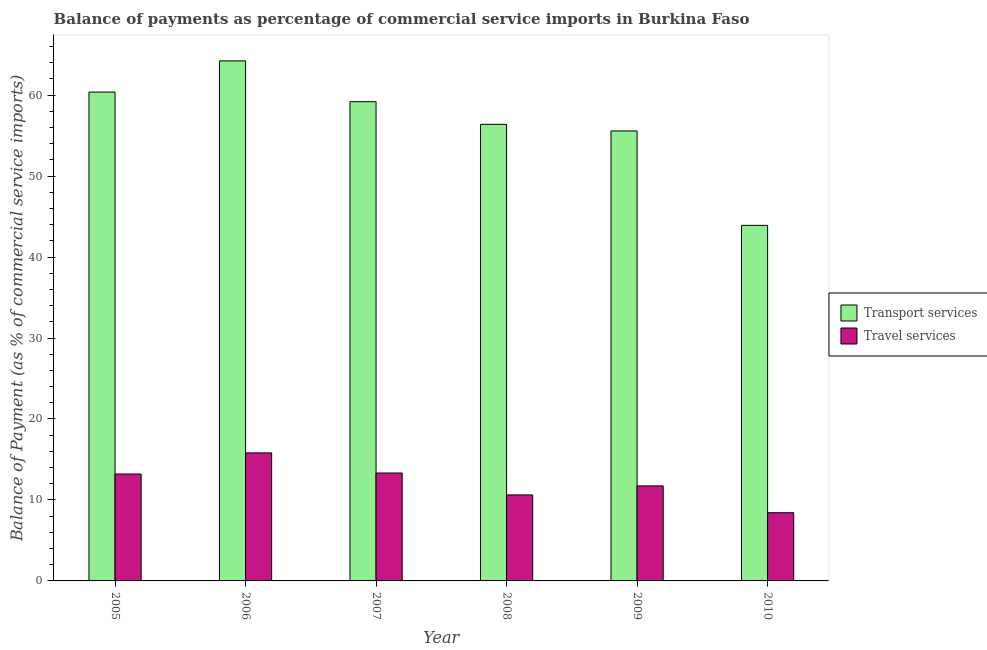How many groups of bars are there?
Provide a short and direct response. 6. How many bars are there on the 3rd tick from the left?
Give a very brief answer. 2. In how many cases, is the number of bars for a given year not equal to the number of legend labels?
Offer a terse response. 0. What is the balance of payments of transport services in 2006?
Ensure brevity in your answer.  64.23. Across all years, what is the maximum balance of payments of travel services?
Provide a succinct answer. 15.81. Across all years, what is the minimum balance of payments of travel services?
Keep it short and to the point. 8.42. What is the total balance of payments of transport services in the graph?
Your answer should be very brief. 339.65. What is the difference between the balance of payments of travel services in 2009 and that in 2010?
Your answer should be compact. 3.31. What is the difference between the balance of payments of transport services in 2006 and the balance of payments of travel services in 2008?
Keep it short and to the point. 7.84. What is the average balance of payments of travel services per year?
Provide a succinct answer. 12.19. In the year 2010, what is the difference between the balance of payments of travel services and balance of payments of transport services?
Ensure brevity in your answer.  0. In how many years, is the balance of payments of transport services greater than 58 %?
Make the answer very short. 3. What is the ratio of the balance of payments of travel services in 2005 to that in 2009?
Give a very brief answer. 1.13. Is the difference between the balance of payments of travel services in 2007 and 2010 greater than the difference between the balance of payments of transport services in 2007 and 2010?
Ensure brevity in your answer.  No. What is the difference between the highest and the second highest balance of payments of transport services?
Provide a short and direct response. 3.85. What is the difference between the highest and the lowest balance of payments of travel services?
Give a very brief answer. 7.39. Is the sum of the balance of payments of travel services in 2007 and 2008 greater than the maximum balance of payments of transport services across all years?
Offer a terse response. Yes. What does the 1st bar from the left in 2010 represents?
Give a very brief answer. Transport services. What does the 2nd bar from the right in 2010 represents?
Offer a terse response. Transport services. Are all the bars in the graph horizontal?
Keep it short and to the point. No. Are the values on the major ticks of Y-axis written in scientific E-notation?
Offer a very short reply. No. Does the graph contain grids?
Your answer should be very brief. No. Where does the legend appear in the graph?
Make the answer very short. Center right. What is the title of the graph?
Make the answer very short. Balance of payments as percentage of commercial service imports in Burkina Faso. Does "Boys" appear as one of the legend labels in the graph?
Provide a short and direct response. No. What is the label or title of the Y-axis?
Your answer should be compact. Balance of Payment (as % of commercial service imports). What is the Balance of Payment (as % of commercial service imports) in Transport services in 2005?
Ensure brevity in your answer.  60.37. What is the Balance of Payment (as % of commercial service imports) in Travel services in 2005?
Your answer should be very brief. 13.2. What is the Balance of Payment (as % of commercial service imports) in Transport services in 2006?
Offer a very short reply. 64.23. What is the Balance of Payment (as % of commercial service imports) of Travel services in 2006?
Ensure brevity in your answer.  15.81. What is the Balance of Payment (as % of commercial service imports) of Transport services in 2007?
Your response must be concise. 59.19. What is the Balance of Payment (as % of commercial service imports) of Travel services in 2007?
Keep it short and to the point. 13.33. What is the Balance of Payment (as % of commercial service imports) of Transport services in 2008?
Offer a terse response. 56.39. What is the Balance of Payment (as % of commercial service imports) in Travel services in 2008?
Give a very brief answer. 10.62. What is the Balance of Payment (as % of commercial service imports) of Transport services in 2009?
Your response must be concise. 55.57. What is the Balance of Payment (as % of commercial service imports) in Travel services in 2009?
Offer a very short reply. 11.73. What is the Balance of Payment (as % of commercial service imports) in Transport services in 2010?
Your answer should be very brief. 43.91. What is the Balance of Payment (as % of commercial service imports) of Travel services in 2010?
Provide a short and direct response. 8.42. Across all years, what is the maximum Balance of Payment (as % of commercial service imports) in Transport services?
Keep it short and to the point. 64.23. Across all years, what is the maximum Balance of Payment (as % of commercial service imports) of Travel services?
Provide a short and direct response. 15.81. Across all years, what is the minimum Balance of Payment (as % of commercial service imports) in Transport services?
Keep it short and to the point. 43.91. Across all years, what is the minimum Balance of Payment (as % of commercial service imports) of Travel services?
Provide a succinct answer. 8.42. What is the total Balance of Payment (as % of commercial service imports) of Transport services in the graph?
Keep it short and to the point. 339.65. What is the total Balance of Payment (as % of commercial service imports) of Travel services in the graph?
Your answer should be compact. 73.12. What is the difference between the Balance of Payment (as % of commercial service imports) in Transport services in 2005 and that in 2006?
Offer a terse response. -3.85. What is the difference between the Balance of Payment (as % of commercial service imports) in Travel services in 2005 and that in 2006?
Provide a succinct answer. -2.61. What is the difference between the Balance of Payment (as % of commercial service imports) of Transport services in 2005 and that in 2007?
Offer a very short reply. 1.19. What is the difference between the Balance of Payment (as % of commercial service imports) in Travel services in 2005 and that in 2007?
Your answer should be very brief. -0.12. What is the difference between the Balance of Payment (as % of commercial service imports) of Transport services in 2005 and that in 2008?
Ensure brevity in your answer.  3.98. What is the difference between the Balance of Payment (as % of commercial service imports) of Travel services in 2005 and that in 2008?
Offer a terse response. 2.58. What is the difference between the Balance of Payment (as % of commercial service imports) in Transport services in 2005 and that in 2009?
Provide a succinct answer. 4.8. What is the difference between the Balance of Payment (as % of commercial service imports) in Travel services in 2005 and that in 2009?
Your answer should be very brief. 1.47. What is the difference between the Balance of Payment (as % of commercial service imports) of Transport services in 2005 and that in 2010?
Offer a terse response. 16.46. What is the difference between the Balance of Payment (as % of commercial service imports) in Travel services in 2005 and that in 2010?
Provide a succinct answer. 4.78. What is the difference between the Balance of Payment (as % of commercial service imports) of Transport services in 2006 and that in 2007?
Make the answer very short. 5.04. What is the difference between the Balance of Payment (as % of commercial service imports) of Travel services in 2006 and that in 2007?
Give a very brief answer. 2.48. What is the difference between the Balance of Payment (as % of commercial service imports) in Transport services in 2006 and that in 2008?
Offer a terse response. 7.84. What is the difference between the Balance of Payment (as % of commercial service imports) of Travel services in 2006 and that in 2008?
Offer a terse response. 5.19. What is the difference between the Balance of Payment (as % of commercial service imports) in Transport services in 2006 and that in 2009?
Your answer should be compact. 8.66. What is the difference between the Balance of Payment (as % of commercial service imports) in Travel services in 2006 and that in 2009?
Provide a short and direct response. 4.08. What is the difference between the Balance of Payment (as % of commercial service imports) of Transport services in 2006 and that in 2010?
Keep it short and to the point. 20.31. What is the difference between the Balance of Payment (as % of commercial service imports) in Travel services in 2006 and that in 2010?
Offer a very short reply. 7.39. What is the difference between the Balance of Payment (as % of commercial service imports) in Transport services in 2007 and that in 2008?
Make the answer very short. 2.8. What is the difference between the Balance of Payment (as % of commercial service imports) of Travel services in 2007 and that in 2008?
Give a very brief answer. 2.71. What is the difference between the Balance of Payment (as % of commercial service imports) in Transport services in 2007 and that in 2009?
Your answer should be very brief. 3.61. What is the difference between the Balance of Payment (as % of commercial service imports) of Travel services in 2007 and that in 2009?
Provide a succinct answer. 1.59. What is the difference between the Balance of Payment (as % of commercial service imports) in Transport services in 2007 and that in 2010?
Provide a short and direct response. 15.27. What is the difference between the Balance of Payment (as % of commercial service imports) in Travel services in 2007 and that in 2010?
Provide a short and direct response. 4.9. What is the difference between the Balance of Payment (as % of commercial service imports) of Transport services in 2008 and that in 2009?
Your answer should be compact. 0.82. What is the difference between the Balance of Payment (as % of commercial service imports) in Travel services in 2008 and that in 2009?
Your answer should be very brief. -1.11. What is the difference between the Balance of Payment (as % of commercial service imports) of Transport services in 2008 and that in 2010?
Offer a very short reply. 12.48. What is the difference between the Balance of Payment (as % of commercial service imports) of Travel services in 2008 and that in 2010?
Offer a very short reply. 2.2. What is the difference between the Balance of Payment (as % of commercial service imports) of Transport services in 2009 and that in 2010?
Offer a very short reply. 11.66. What is the difference between the Balance of Payment (as % of commercial service imports) of Travel services in 2009 and that in 2010?
Your answer should be very brief. 3.31. What is the difference between the Balance of Payment (as % of commercial service imports) of Transport services in 2005 and the Balance of Payment (as % of commercial service imports) of Travel services in 2006?
Offer a terse response. 44.56. What is the difference between the Balance of Payment (as % of commercial service imports) in Transport services in 2005 and the Balance of Payment (as % of commercial service imports) in Travel services in 2007?
Ensure brevity in your answer.  47.05. What is the difference between the Balance of Payment (as % of commercial service imports) in Transport services in 2005 and the Balance of Payment (as % of commercial service imports) in Travel services in 2008?
Ensure brevity in your answer.  49.75. What is the difference between the Balance of Payment (as % of commercial service imports) of Transport services in 2005 and the Balance of Payment (as % of commercial service imports) of Travel services in 2009?
Your answer should be compact. 48.64. What is the difference between the Balance of Payment (as % of commercial service imports) in Transport services in 2005 and the Balance of Payment (as % of commercial service imports) in Travel services in 2010?
Your answer should be very brief. 51.95. What is the difference between the Balance of Payment (as % of commercial service imports) of Transport services in 2006 and the Balance of Payment (as % of commercial service imports) of Travel services in 2007?
Give a very brief answer. 50.9. What is the difference between the Balance of Payment (as % of commercial service imports) of Transport services in 2006 and the Balance of Payment (as % of commercial service imports) of Travel services in 2008?
Provide a succinct answer. 53.61. What is the difference between the Balance of Payment (as % of commercial service imports) in Transport services in 2006 and the Balance of Payment (as % of commercial service imports) in Travel services in 2009?
Make the answer very short. 52.49. What is the difference between the Balance of Payment (as % of commercial service imports) in Transport services in 2006 and the Balance of Payment (as % of commercial service imports) in Travel services in 2010?
Offer a terse response. 55.8. What is the difference between the Balance of Payment (as % of commercial service imports) in Transport services in 2007 and the Balance of Payment (as % of commercial service imports) in Travel services in 2008?
Give a very brief answer. 48.56. What is the difference between the Balance of Payment (as % of commercial service imports) of Transport services in 2007 and the Balance of Payment (as % of commercial service imports) of Travel services in 2009?
Keep it short and to the point. 47.45. What is the difference between the Balance of Payment (as % of commercial service imports) of Transport services in 2007 and the Balance of Payment (as % of commercial service imports) of Travel services in 2010?
Provide a succinct answer. 50.76. What is the difference between the Balance of Payment (as % of commercial service imports) in Transport services in 2008 and the Balance of Payment (as % of commercial service imports) in Travel services in 2009?
Give a very brief answer. 44.65. What is the difference between the Balance of Payment (as % of commercial service imports) of Transport services in 2008 and the Balance of Payment (as % of commercial service imports) of Travel services in 2010?
Provide a short and direct response. 47.97. What is the difference between the Balance of Payment (as % of commercial service imports) of Transport services in 2009 and the Balance of Payment (as % of commercial service imports) of Travel services in 2010?
Your answer should be very brief. 47.15. What is the average Balance of Payment (as % of commercial service imports) of Transport services per year?
Ensure brevity in your answer.  56.61. What is the average Balance of Payment (as % of commercial service imports) in Travel services per year?
Ensure brevity in your answer.  12.19. In the year 2005, what is the difference between the Balance of Payment (as % of commercial service imports) in Transport services and Balance of Payment (as % of commercial service imports) in Travel services?
Your answer should be compact. 47.17. In the year 2006, what is the difference between the Balance of Payment (as % of commercial service imports) in Transport services and Balance of Payment (as % of commercial service imports) in Travel services?
Your answer should be compact. 48.42. In the year 2007, what is the difference between the Balance of Payment (as % of commercial service imports) of Transport services and Balance of Payment (as % of commercial service imports) of Travel services?
Make the answer very short. 45.86. In the year 2008, what is the difference between the Balance of Payment (as % of commercial service imports) of Transport services and Balance of Payment (as % of commercial service imports) of Travel services?
Give a very brief answer. 45.77. In the year 2009, what is the difference between the Balance of Payment (as % of commercial service imports) of Transport services and Balance of Payment (as % of commercial service imports) of Travel services?
Provide a short and direct response. 43.84. In the year 2010, what is the difference between the Balance of Payment (as % of commercial service imports) of Transport services and Balance of Payment (as % of commercial service imports) of Travel services?
Provide a short and direct response. 35.49. What is the ratio of the Balance of Payment (as % of commercial service imports) of Travel services in 2005 to that in 2006?
Your answer should be very brief. 0.83. What is the ratio of the Balance of Payment (as % of commercial service imports) in Transport services in 2005 to that in 2007?
Your answer should be compact. 1.02. What is the ratio of the Balance of Payment (as % of commercial service imports) of Transport services in 2005 to that in 2008?
Make the answer very short. 1.07. What is the ratio of the Balance of Payment (as % of commercial service imports) in Travel services in 2005 to that in 2008?
Your answer should be compact. 1.24. What is the ratio of the Balance of Payment (as % of commercial service imports) in Transport services in 2005 to that in 2009?
Ensure brevity in your answer.  1.09. What is the ratio of the Balance of Payment (as % of commercial service imports) in Travel services in 2005 to that in 2009?
Give a very brief answer. 1.13. What is the ratio of the Balance of Payment (as % of commercial service imports) in Transport services in 2005 to that in 2010?
Your response must be concise. 1.37. What is the ratio of the Balance of Payment (as % of commercial service imports) in Travel services in 2005 to that in 2010?
Make the answer very short. 1.57. What is the ratio of the Balance of Payment (as % of commercial service imports) in Transport services in 2006 to that in 2007?
Offer a very short reply. 1.09. What is the ratio of the Balance of Payment (as % of commercial service imports) of Travel services in 2006 to that in 2007?
Your response must be concise. 1.19. What is the ratio of the Balance of Payment (as % of commercial service imports) in Transport services in 2006 to that in 2008?
Keep it short and to the point. 1.14. What is the ratio of the Balance of Payment (as % of commercial service imports) in Travel services in 2006 to that in 2008?
Your response must be concise. 1.49. What is the ratio of the Balance of Payment (as % of commercial service imports) in Transport services in 2006 to that in 2009?
Keep it short and to the point. 1.16. What is the ratio of the Balance of Payment (as % of commercial service imports) in Travel services in 2006 to that in 2009?
Offer a very short reply. 1.35. What is the ratio of the Balance of Payment (as % of commercial service imports) in Transport services in 2006 to that in 2010?
Ensure brevity in your answer.  1.46. What is the ratio of the Balance of Payment (as % of commercial service imports) of Travel services in 2006 to that in 2010?
Provide a succinct answer. 1.88. What is the ratio of the Balance of Payment (as % of commercial service imports) in Transport services in 2007 to that in 2008?
Ensure brevity in your answer.  1.05. What is the ratio of the Balance of Payment (as % of commercial service imports) in Travel services in 2007 to that in 2008?
Ensure brevity in your answer.  1.25. What is the ratio of the Balance of Payment (as % of commercial service imports) of Transport services in 2007 to that in 2009?
Your answer should be very brief. 1.06. What is the ratio of the Balance of Payment (as % of commercial service imports) of Travel services in 2007 to that in 2009?
Your answer should be compact. 1.14. What is the ratio of the Balance of Payment (as % of commercial service imports) of Transport services in 2007 to that in 2010?
Offer a very short reply. 1.35. What is the ratio of the Balance of Payment (as % of commercial service imports) in Travel services in 2007 to that in 2010?
Your answer should be very brief. 1.58. What is the ratio of the Balance of Payment (as % of commercial service imports) of Transport services in 2008 to that in 2009?
Offer a very short reply. 1.01. What is the ratio of the Balance of Payment (as % of commercial service imports) of Travel services in 2008 to that in 2009?
Your answer should be very brief. 0.91. What is the ratio of the Balance of Payment (as % of commercial service imports) in Transport services in 2008 to that in 2010?
Provide a short and direct response. 1.28. What is the ratio of the Balance of Payment (as % of commercial service imports) of Travel services in 2008 to that in 2010?
Your answer should be compact. 1.26. What is the ratio of the Balance of Payment (as % of commercial service imports) of Transport services in 2009 to that in 2010?
Provide a succinct answer. 1.27. What is the ratio of the Balance of Payment (as % of commercial service imports) in Travel services in 2009 to that in 2010?
Your response must be concise. 1.39. What is the difference between the highest and the second highest Balance of Payment (as % of commercial service imports) of Transport services?
Make the answer very short. 3.85. What is the difference between the highest and the second highest Balance of Payment (as % of commercial service imports) in Travel services?
Keep it short and to the point. 2.48. What is the difference between the highest and the lowest Balance of Payment (as % of commercial service imports) in Transport services?
Make the answer very short. 20.31. What is the difference between the highest and the lowest Balance of Payment (as % of commercial service imports) of Travel services?
Ensure brevity in your answer.  7.39. 